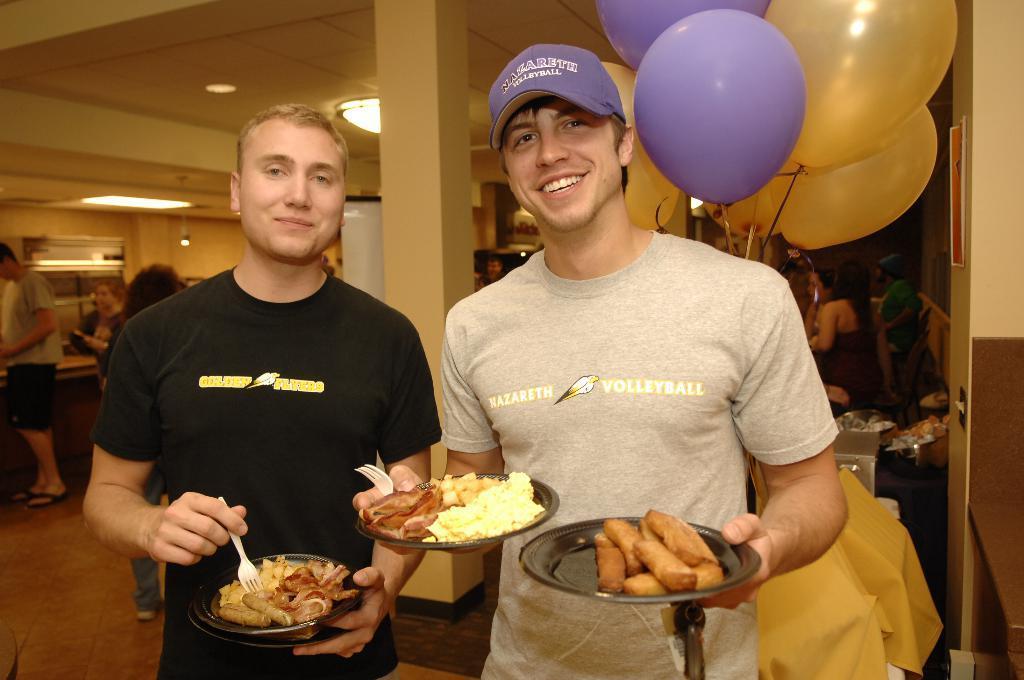Can you describe this image briefly? In front of the picture, we see two men are standing. The man on the right side is wearing a violet cap and he is holding the fork and the two plates containing the food. Beside him, we see a man in the black T-shirt is holding the two plates containing food and a fork. Both of them are smiling and they are posing for the photo. Behind them, we see a yellow cloth and a pillar. We see the balloons in yellow and violet color. We see the people are sitting on the chairs. On the right side, we see a wall in white and brown color. On the left side, we see three men are standing. Beside them, we see a countertop and a white color object. In the background, we see a wall and a projector screen. At the top, we see the lights and the ceiling of the room. 